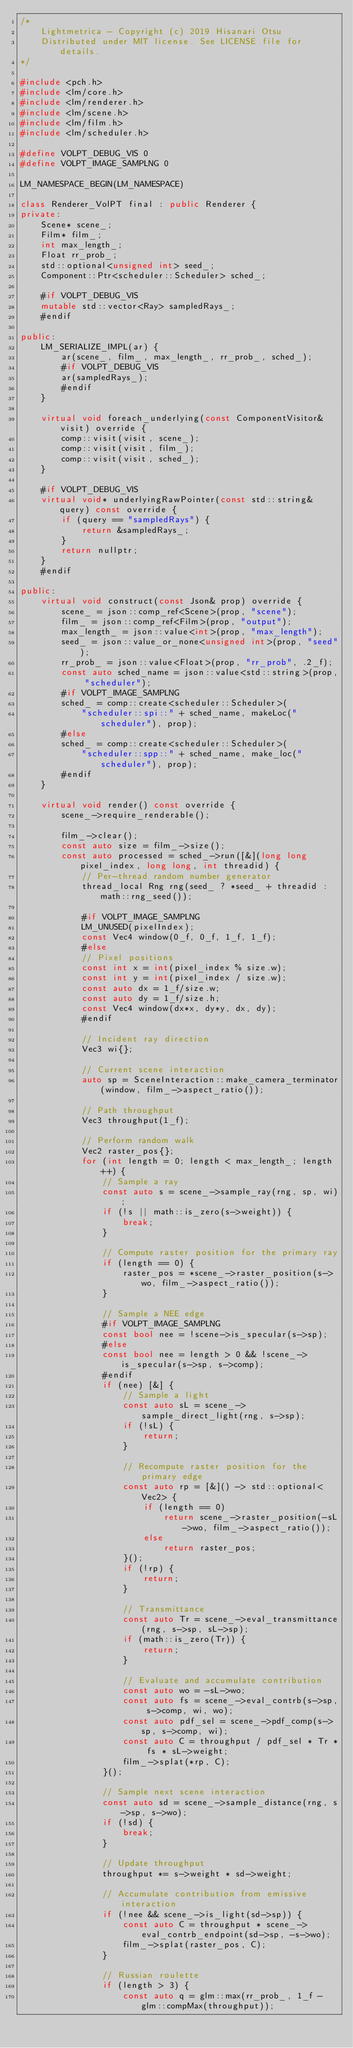<code> <loc_0><loc_0><loc_500><loc_500><_C++_>/*
    Lightmetrica - Copyright (c) 2019 Hisanari Otsu
    Distributed under MIT license. See LICENSE file for details.
*/

#include <pch.h>
#include <lm/core.h>
#include <lm/renderer.h>
#include <lm/scene.h>
#include <lm/film.h>
#include <lm/scheduler.h>

#define VOLPT_DEBUG_VIS 0
#define VOLPT_IMAGE_SAMPLNG 0

LM_NAMESPACE_BEGIN(LM_NAMESPACE)

class Renderer_VolPT final : public Renderer {
private:
    Scene* scene_;
    Film* film_;
    int max_length_;
    Float rr_prob_;
    std::optional<unsigned int> seed_;
    Component::Ptr<scheduler::Scheduler> sched_;

    #if VOLPT_DEBUG_VIS
    mutable std::vector<Ray> sampledRays_;
    #endif

public:
    LM_SERIALIZE_IMPL(ar) {
        ar(scene_, film_, max_length_, rr_prob_, sched_);
        #if VOLPT_DEBUG_VIS
        ar(sampledRays_);
        #endif
    }

    virtual void foreach_underlying(const ComponentVisitor& visit) override {
        comp::visit(visit, scene_);
        comp::visit(visit, film_);
        comp::visit(visit, sched_);
    }

    #if VOLPT_DEBUG_VIS
    virtual void* underlyingRawPointer(const std::string& query) const override {
        if (query == "sampledRays") {
            return &sampledRays_;
        }
        return nullptr;
    }
    #endif

public:
    virtual void construct(const Json& prop) override {
        scene_ = json::comp_ref<Scene>(prop, "scene");
        film_ = json::comp_ref<Film>(prop, "output");
        max_length_ = json::value<int>(prop, "max_length");
        seed_ = json::value_or_none<unsigned int>(prop, "seed");
        rr_prob_ = json::value<Float>(prop, "rr_prob", .2_f);
        const auto sched_name = json::value<std::string>(prop, "scheduler");
        #if VOLPT_IMAGE_SAMPLNG
        sched_ = comp::create<scheduler::Scheduler>(
            "scheduler::spi::" + sched_name, makeLoc("scheduler"), prop);
        #else
        sched_ = comp::create<scheduler::Scheduler>(
            "scheduler::spp::" + sched_name, make_loc("scheduler"), prop);
        #endif
    }

    virtual void render() const override {
		scene_->require_renderable();

        film_->clear();
        const auto size = film_->size();
        const auto processed = sched_->run([&](long long pixel_index, long long, int threadid) {
            // Per-thread random number generator
            thread_local Rng rng(seed_ ? *seed_ + threadid : math::rng_seed());

            #if VOLPT_IMAGE_SAMPLNG
            LM_UNUSED(pixelIndex);
            const Vec4 window(0_f, 0_f, 1_f, 1_f);
            #else
            // Pixel positions
            const int x = int(pixel_index % size.w);
            const int y = int(pixel_index / size.w);
            const auto dx = 1_f/size.w;
            const auto dy = 1_f/size.h;
            const Vec4 window(dx*x, dy*y, dx, dy);
            #endif

            // Incident ray direction
            Vec3 wi{};

            // Current scene interaction
            auto sp = SceneInteraction::make_camera_terminator(window, film_->aspect_ratio());

            // Path throughput
            Vec3 throughput(1_f);

            // Perform random walk
            Vec2 raster_pos{};
            for (int length = 0; length < max_length_; length++) {
                // Sample a ray
                const auto s = scene_->sample_ray(rng, sp, wi);
                if (!s || math::is_zero(s->weight)) {
                    break;
                }

                // Compute raster position for the primary ray
                if (length == 0) {
                    raster_pos = *scene_->raster_position(s->wo, film_->aspect_ratio());
                }

                // Sample a NEE edge
                #if VOLPT_IMAGE_SAMPLNG
                const bool nee = !scene->is_specular(s->sp);
                #else
                const bool nee = length > 0 && !scene_->is_specular(s->sp, s->comp);
                #endif
                if (nee) [&] {
                    // Sample a light
                    const auto sL = scene_->sample_direct_light(rng, s->sp);
                    if (!sL) {
                        return;
                    }

                    // Recompute raster position for the primary edge
                    const auto rp = [&]() -> std::optional<Vec2> {
                        if (length == 0)
                            return scene_->raster_position(-sL->wo, film_->aspect_ratio());
                        else
                            return raster_pos;
                    }();
                    if (!rp) {
                        return;
                    }
                    
                    // Transmittance
                    const auto Tr = scene_->eval_transmittance(rng, s->sp, sL->sp);
                    if (math::is_zero(Tr)) {
                        return;
                    }

                    // Evaluate and accumulate contribution
                    const auto wo = -sL->wo;
                    const auto fs = scene_->eval_contrb(s->sp, s->comp, wi, wo);
                    const auto pdf_sel = scene_->pdf_comp(s->sp, s->comp, wi);
                    const auto C = throughput / pdf_sel * Tr * fs * sL->weight;
                    film_->splat(*rp, C);
                }();

                // Sample next scene interaction
                const auto sd = scene_->sample_distance(rng, s->sp, s->wo);
                if (!sd) {
                    break;
                }

                // Update throughput
                throughput *= s->weight * sd->weight;

                // Accumulate contribution from emissive interaction
                if (!nee && scene_->is_light(sd->sp)) {
                    const auto C = throughput * scene_->eval_contrb_endpoint(sd->sp, -s->wo);
                    film_->splat(raster_pos, C);
                }

                // Russian roulette
                if (length > 3) {
                    const auto q = glm::max(rr_prob_, 1_f - glm::compMax(throughput));</code> 